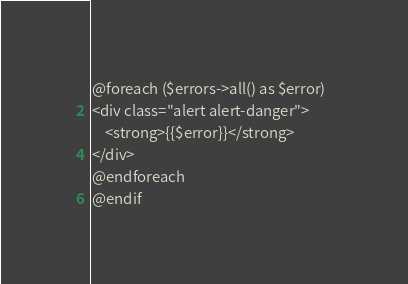Convert code to text. <code><loc_0><loc_0><loc_500><loc_500><_PHP_>@foreach ($errors->all() as $error)  
<div class="alert alert-danger">
    <strong>{{$error}}</strong> 
</div> 
@endforeach  
@endif  
</code> 